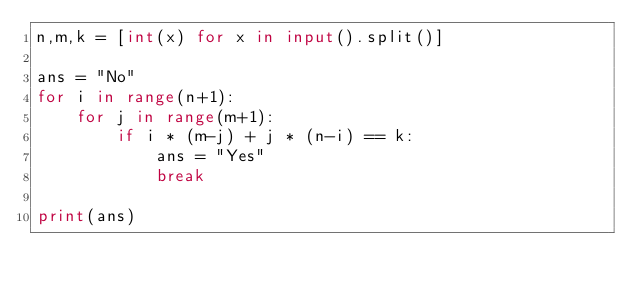<code> <loc_0><loc_0><loc_500><loc_500><_Python_>n,m,k = [int(x) for x in input().split()]

ans = "No"
for i in range(n+1):
    for j in range(m+1):
        if i * (m-j) + j * (n-i) == k:
            ans = "Yes"
            break

print(ans)</code> 